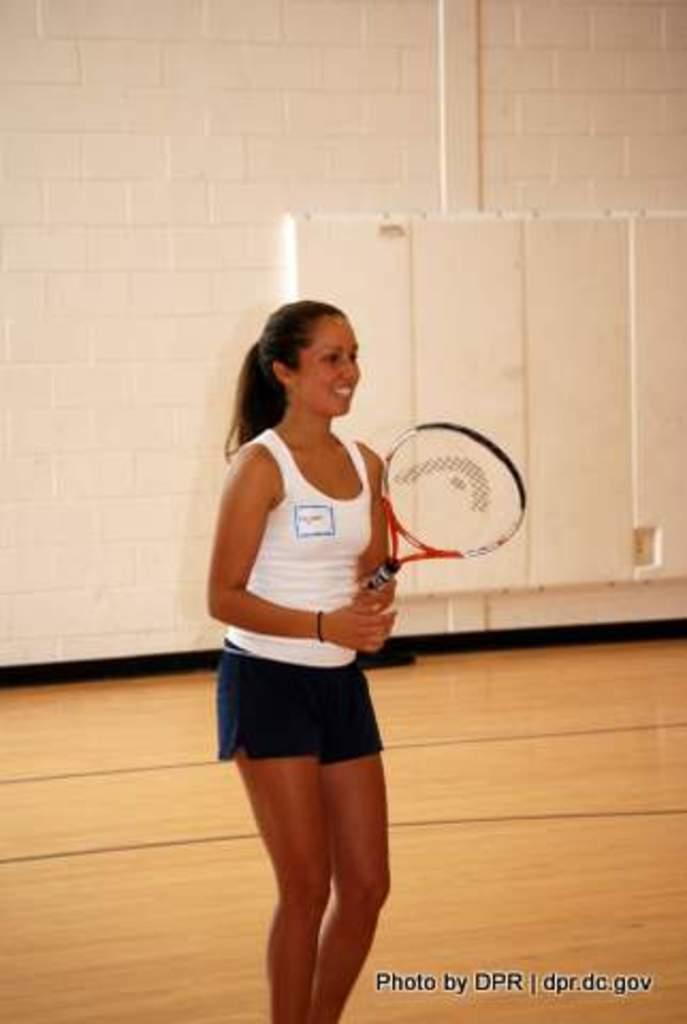In one or two sentences, can you explain what this image depicts? She is standing. She is smiling. She is holding a bat. We can see in background white color wall. 